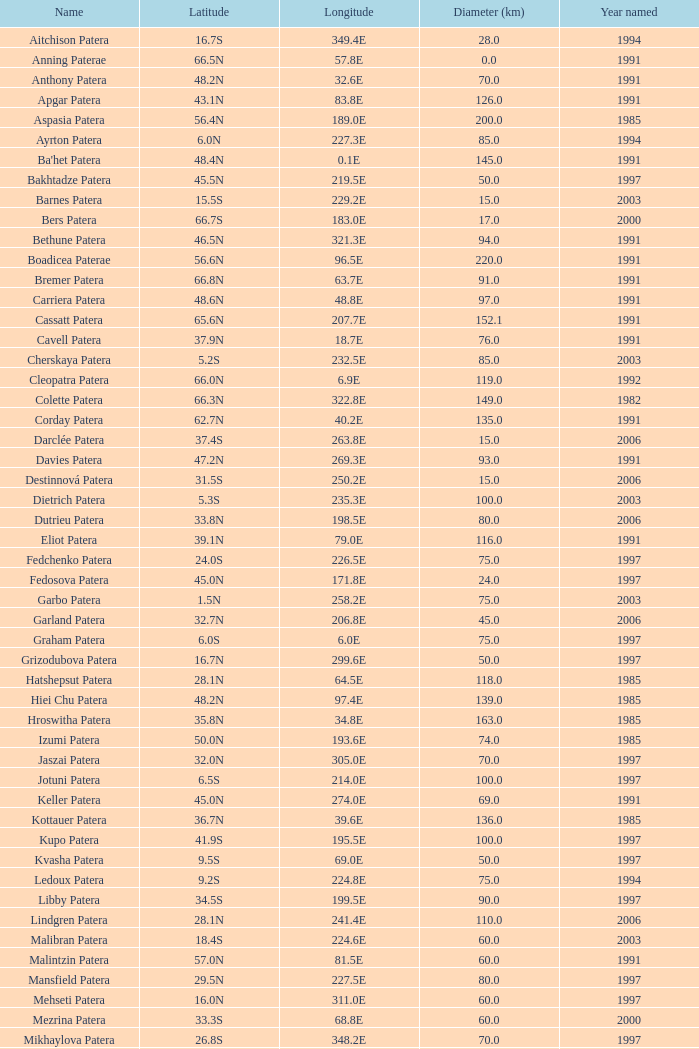I'm looking to parse the entire table for insights. Could you assist me with that? {'header': ['Name', 'Latitude', 'Longitude', 'Diameter (km)', 'Year named'], 'rows': [['Aitchison Patera', '16.7S', '349.4E', '28.0', '1994'], ['Anning Paterae', '66.5N', '57.8E', '0.0', '1991'], ['Anthony Patera', '48.2N', '32.6E', '70.0', '1991'], ['Apgar Patera', '43.1N', '83.8E', '126.0', '1991'], ['Aspasia Patera', '56.4N', '189.0E', '200.0', '1985'], ['Ayrton Patera', '6.0N', '227.3E', '85.0', '1994'], ["Ba'het Patera", '48.4N', '0.1E', '145.0', '1991'], ['Bakhtadze Patera', '45.5N', '219.5E', '50.0', '1997'], ['Barnes Patera', '15.5S', '229.2E', '15.0', '2003'], ['Bers Patera', '66.7S', '183.0E', '17.0', '2000'], ['Bethune Patera', '46.5N', '321.3E', '94.0', '1991'], ['Boadicea Paterae', '56.6N', '96.5E', '220.0', '1991'], ['Bremer Patera', '66.8N', '63.7E', '91.0', '1991'], ['Carriera Patera', '48.6N', '48.8E', '97.0', '1991'], ['Cassatt Patera', '65.6N', '207.7E', '152.1', '1991'], ['Cavell Patera', '37.9N', '18.7E', '76.0', '1991'], ['Cherskaya Patera', '5.2S', '232.5E', '85.0', '2003'], ['Cleopatra Patera', '66.0N', '6.9E', '119.0', '1992'], ['Colette Patera', '66.3N', '322.8E', '149.0', '1982'], ['Corday Patera', '62.7N', '40.2E', '135.0', '1991'], ['Darclée Patera', '37.4S', '263.8E', '15.0', '2006'], ['Davies Patera', '47.2N', '269.3E', '93.0', '1991'], ['Destinnová Patera', '31.5S', '250.2E', '15.0', '2006'], ['Dietrich Patera', '5.3S', '235.3E', '100.0', '2003'], ['Dutrieu Patera', '33.8N', '198.5E', '80.0', '2006'], ['Eliot Patera', '39.1N', '79.0E', '116.0', '1991'], ['Fedchenko Patera', '24.0S', '226.5E', '75.0', '1997'], ['Fedosova Patera', '45.0N', '171.8E', '24.0', '1997'], ['Garbo Patera', '1.5N', '258.2E', '75.0', '2003'], ['Garland Patera', '32.7N', '206.8E', '45.0', '2006'], ['Graham Patera', '6.0S', '6.0E', '75.0', '1997'], ['Grizodubova Patera', '16.7N', '299.6E', '50.0', '1997'], ['Hatshepsut Patera', '28.1N', '64.5E', '118.0', '1985'], ['Hiei Chu Patera', '48.2N', '97.4E', '139.0', '1985'], ['Hroswitha Patera', '35.8N', '34.8E', '163.0', '1985'], ['Izumi Patera', '50.0N', '193.6E', '74.0', '1985'], ['Jaszai Patera', '32.0N', '305.0E', '70.0', '1997'], ['Jotuni Patera', '6.5S', '214.0E', '100.0', '1997'], ['Keller Patera', '45.0N', '274.0E', '69.0', '1991'], ['Kottauer Patera', '36.7N', '39.6E', '136.0', '1985'], ['Kupo Patera', '41.9S', '195.5E', '100.0', '1997'], ['Kvasha Patera', '9.5S', '69.0E', '50.0', '1997'], ['Ledoux Patera', '9.2S', '224.8E', '75.0', '1994'], ['Libby Patera', '34.5S', '199.5E', '90.0', '1997'], ['Lindgren Patera', '28.1N', '241.4E', '110.0', '2006'], ['Malibran Patera', '18.4S', '224.6E', '60.0', '2003'], ['Malintzin Patera', '57.0N', '81.5E', '60.0', '1991'], ['Mansfield Patera', '29.5N', '227.5E', '80.0', '1997'], ['Mehseti Patera', '16.0N', '311.0E', '60.0', '1997'], ['Mezrina Patera', '33.3S', '68.8E', '60.0', '2000'], ['Mikhaylova Patera', '26.8S', '348.2E', '70.0', '1997'], ['Nikolaeva Patera', '33.9N', '267.5E', '100.0', '2006'], ['Nordenflycht Patera', '35.0S', '266.0E', '140.0', '1997'], ['Nzingha Patera', '68.7N', '205.7E', '85.5', '1991'], ['Panina Patera', '13.0S', '309.8E', '50.0', '1997'], ['Payne-Gaposchkin Patera', '25.5S', '196.0E', '100.0', '1997'], ['Pchilka Patera', '26.5N', '234.0E', '100.0', '1997'], ['Pocahontas Patera', '64.9N', '49.4E', '78.0', '1991'], ['Raskova Paterae', '51.0S', '222.8E', '80.0', '1994'], ['Razia Patera', '46.2N', '197.8E', '157.0', '1985'], ['Rogneda Patera', '2.8S', '220.5E', '120.0', '2003'], ['Sacajawea Patera', '64.3N', '335.4E', '233.0', '1982'], ['Sachs Patera', '49.1N', '334.2E', '65.0', '1991'], ['Sand Patera', '41.7N', '15.5E', '181.0', '1991'], ['Sappho Patera', '14.1N', '16.5E', '225.0', '1979'], ['Schumann-Heink Patera', '74.3N', '214.5E', '121.7', '1991'], ['Serova Patera', '20.0N', '247.0E', '60.0', '1997'], ['Shelikhova Patera', '75.7S', '162.5E', '60.0', '1997'], ['Shulzhenko Patera', '6.5N', '264.5E', '60.0', '1997'], ['Siddons Patera', '61.6N', '340.6E', '47.0', '1997'], ['Stopes Patera', '42.6N', '46.5E', '169.0', '1991'], ['Tarbell Patera', '58.2S', '351.5E', '80.0', '1994'], ['Teasdale Patera', '67.6S', '189.1E', '75.0', '1994'], ['Tenisheva Patera', '1.4S', '254.8E', '80.0', '2000'], ['Tey Patera', '17.8S', '349.1E', '20.0', '1994'], ['Theodora Patera', '23.0N', '280.0E', '0.0', '1982'], ['Tipporah Patera', '38.9N', '43.0E', '99.0', '1985'], ['Tituba Patera', '42.4N', '214.7E', '163.0', '1991'], ['Trotula Patera', '41.3N', '18.9E', '146.0', '1985'], ['Viardot Patera', '7.0S', '254.3E', '55.0', '2000'], ['Vibert-Douglas Patera', '11.6S', '194.3E', '45.0', '2003'], ['Villepreux-Power Patera', '22.0S', '210.0E', '100.0', '1997'], ['Vovchok Patera', '38.0S', '310.0E', '80.0', '1997'], ['Wilde Patera', '21.3S', '266.3E', '75.0', '2000'], ['Witte Patera', '25.8S', '247.65E', '35.0', '2006'], ['Woodhull Patera', '37.4N', '305.4E', '83.0', '1991'], ['Yaroslavna Patera', '38.8N', '21.2E', '112.0', '1985'], ['Žemaite Patera', '35.0S', '263.0E', '60.0', '1997']]} What is Longitude, when Name is Raskova Paterae? 222.8E. 